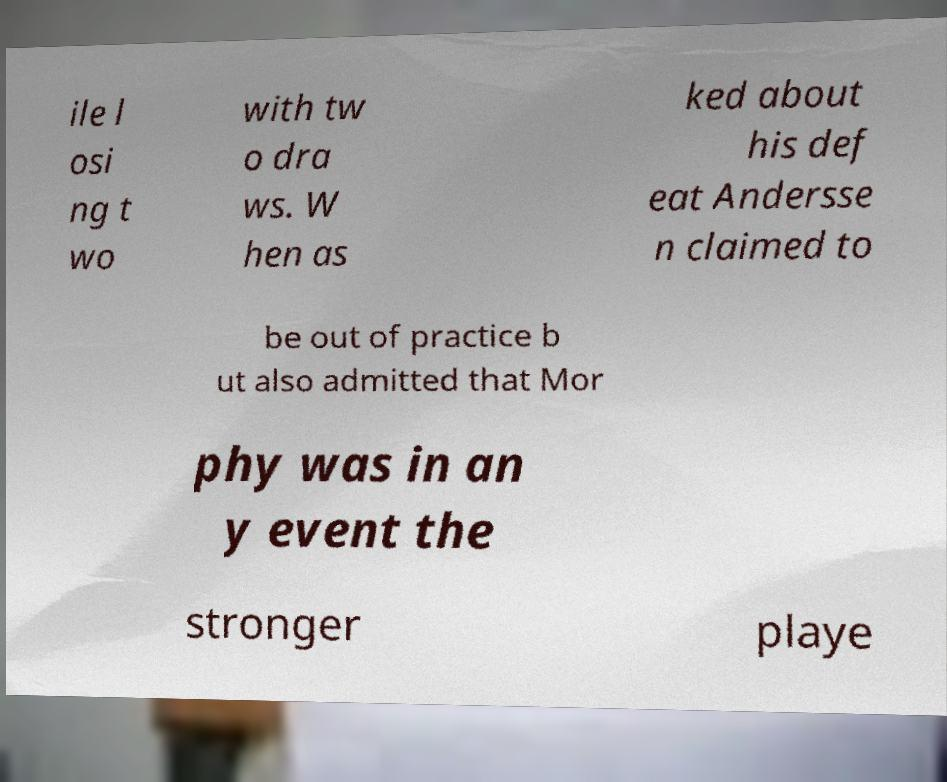Can you read and provide the text displayed in the image?This photo seems to have some interesting text. Can you extract and type it out for me? ile l osi ng t wo with tw o dra ws. W hen as ked about his def eat Andersse n claimed to be out of practice b ut also admitted that Mor phy was in an y event the stronger playe 